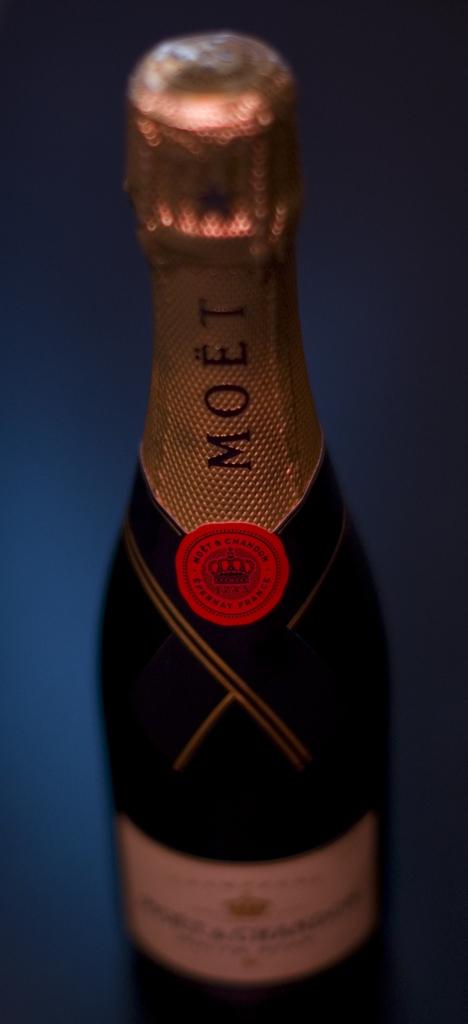What is the name of this wine?
Provide a succinct answer. Moet. 